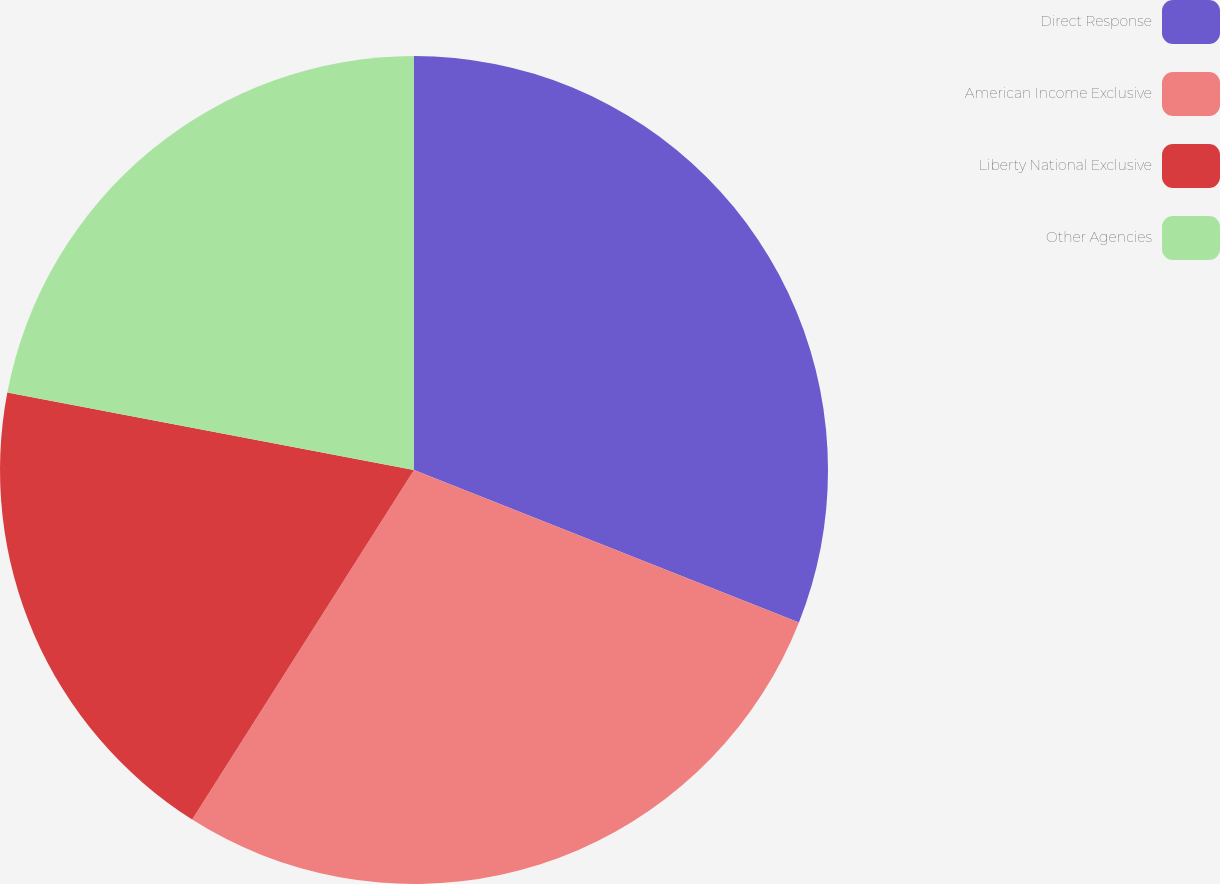Convert chart to OTSL. <chart><loc_0><loc_0><loc_500><loc_500><pie_chart><fcel>Direct Response<fcel>American Income Exclusive<fcel>Liberty National Exclusive<fcel>Other Agencies<nl><fcel>31.0%<fcel>28.0%<fcel>19.0%<fcel>22.0%<nl></chart> 